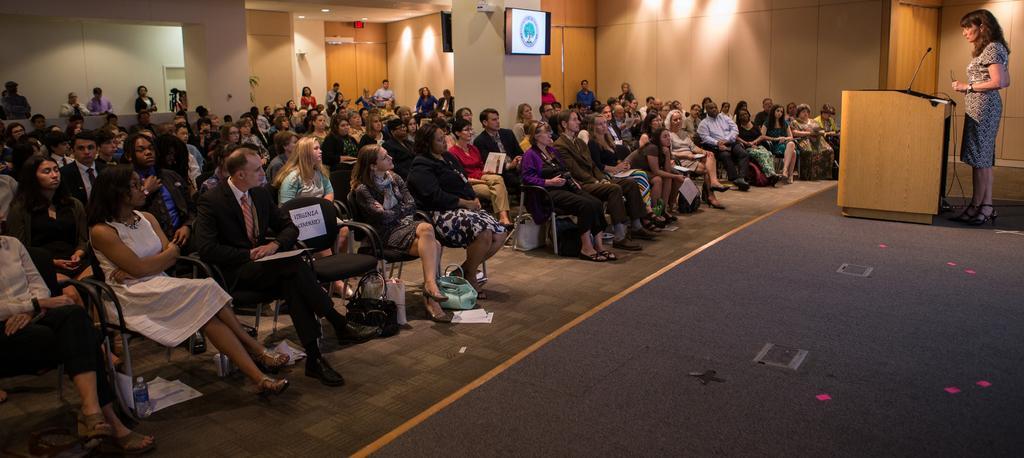Please provide a concise description of this image. In this picture I can see group of people sitting on the chairs. There are paper, bags and some other objects. There is a woman standing near the podium and there is a mike on the podium, and in the background there are televisions attached to the pillar and there are lights. 